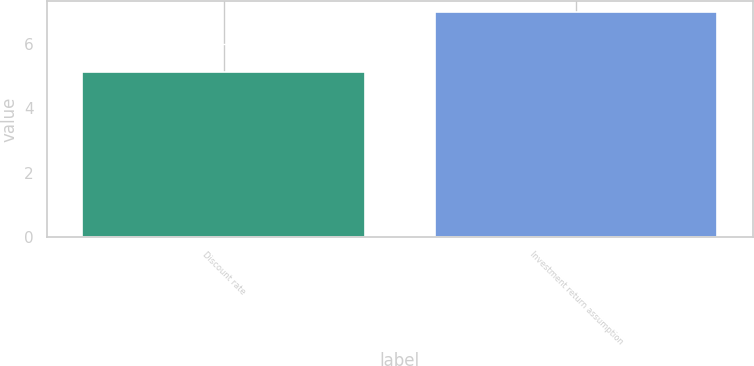Convert chart. <chart><loc_0><loc_0><loc_500><loc_500><bar_chart><fcel>Discount rate<fcel>Investment return assumption<nl><fcel>5.15<fcel>7<nl></chart> 